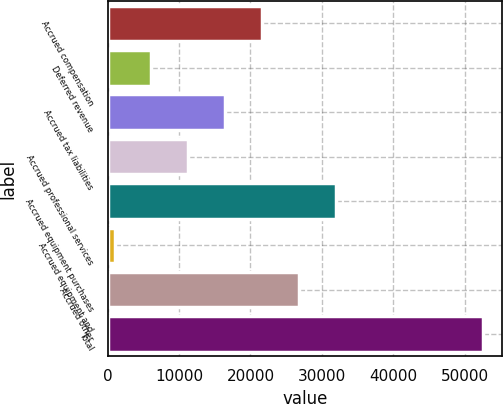Convert chart to OTSL. <chart><loc_0><loc_0><loc_500><loc_500><bar_chart><fcel>Accrued compensation<fcel>Deferred revenue<fcel>Accrued tax liabilities<fcel>Accrued professional services<fcel>Accrued equipment purchases<fcel>Accrued equipment and<fcel>Accrued other<fcel>Total<nl><fcel>21608.4<fcel>6107.1<fcel>16441.3<fcel>11274.2<fcel>31942.6<fcel>940<fcel>26775.5<fcel>52611<nl></chart> 